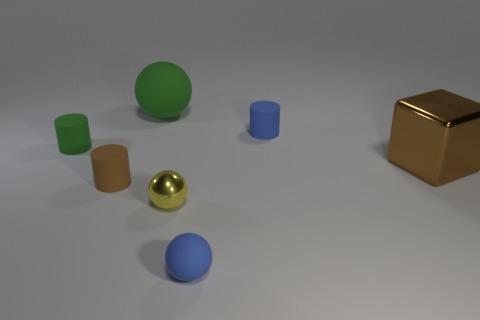Add 1 matte balls. How many objects exist? 8 Subtract all balls. How many objects are left? 4 Add 2 big rubber things. How many big rubber things exist? 3 Subtract 0 gray blocks. How many objects are left? 7 Subtract all large blue shiny balls. Subtract all large brown shiny blocks. How many objects are left? 6 Add 7 brown metal blocks. How many brown metal blocks are left? 8 